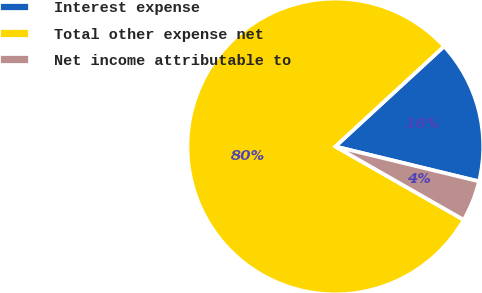Convert chart. <chart><loc_0><loc_0><loc_500><loc_500><pie_chart><fcel>Interest expense<fcel>Total other expense net<fcel>Net income attributable to<nl><fcel>15.64%<fcel>79.89%<fcel>4.47%<nl></chart> 